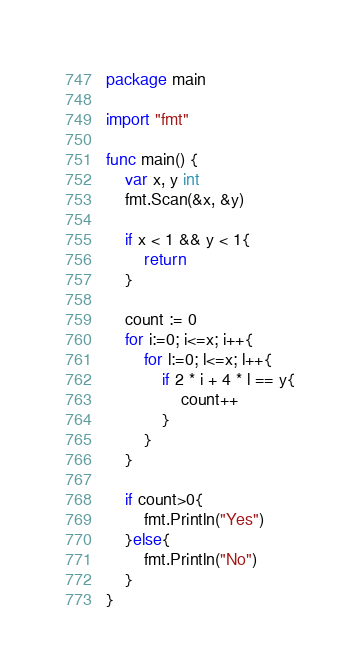<code> <loc_0><loc_0><loc_500><loc_500><_Go_>package main

import "fmt"

func main() {
	var x, y int
	fmt.Scan(&x, &y)

	if x < 1 && y < 1{
		return
	}

	count := 0
	for i:=0; i<=x; i++{
		for l:=0; l<=x; l++{
			if 2 * i + 4 * l == y{
				count++
			}
		}
	}

	if count>0{
		fmt.Println("Yes")
	}else{
		fmt.Println("No")
	}
}</code> 